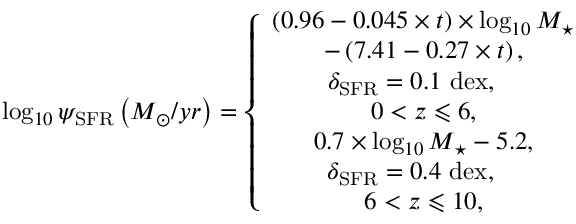Convert formula to latex. <formula><loc_0><loc_0><loc_500><loc_500>\log _ { 1 0 } \psi _ { S F R } \left ( M _ { \odot } / y r \right ) = \left \{ \begin{array} { c } { \left ( 0 . 9 6 - 0 . 0 4 5 \times t \right ) \times \log _ { 1 0 } M _ { ^ { * } } } \\ { - \left ( 7 . 4 1 - 0 . 2 7 \times t \right ) , } \\ { \delta _ { S F R } = 0 . 1 d e x , \quad } \\ { { 0 < z \leqslant 6 } , } \\ { 0 . 7 \times \log _ { 1 0 } M _ { ^ { * } } - 5 . 2 , } \\ { \, \delta _ { S F R } = 0 . 4 d e x , \quad } \\ { { 6 < z \leqslant 1 0 } , } \end{array}</formula> 